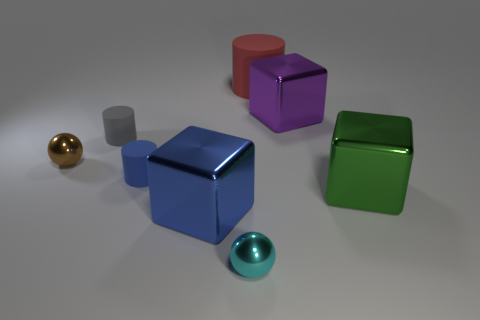Add 2 red blocks. How many objects exist? 10 Subtract all balls. How many objects are left? 6 Add 7 metal spheres. How many metal spheres exist? 9 Subtract 1 blue cubes. How many objects are left? 7 Subtract all brown things. Subtract all gray matte objects. How many objects are left? 6 Add 2 tiny things. How many tiny things are left? 6 